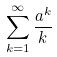<formula> <loc_0><loc_0><loc_500><loc_500>\sum _ { k = 1 } ^ { \infty } \frac { a ^ { k } } { k }</formula> 